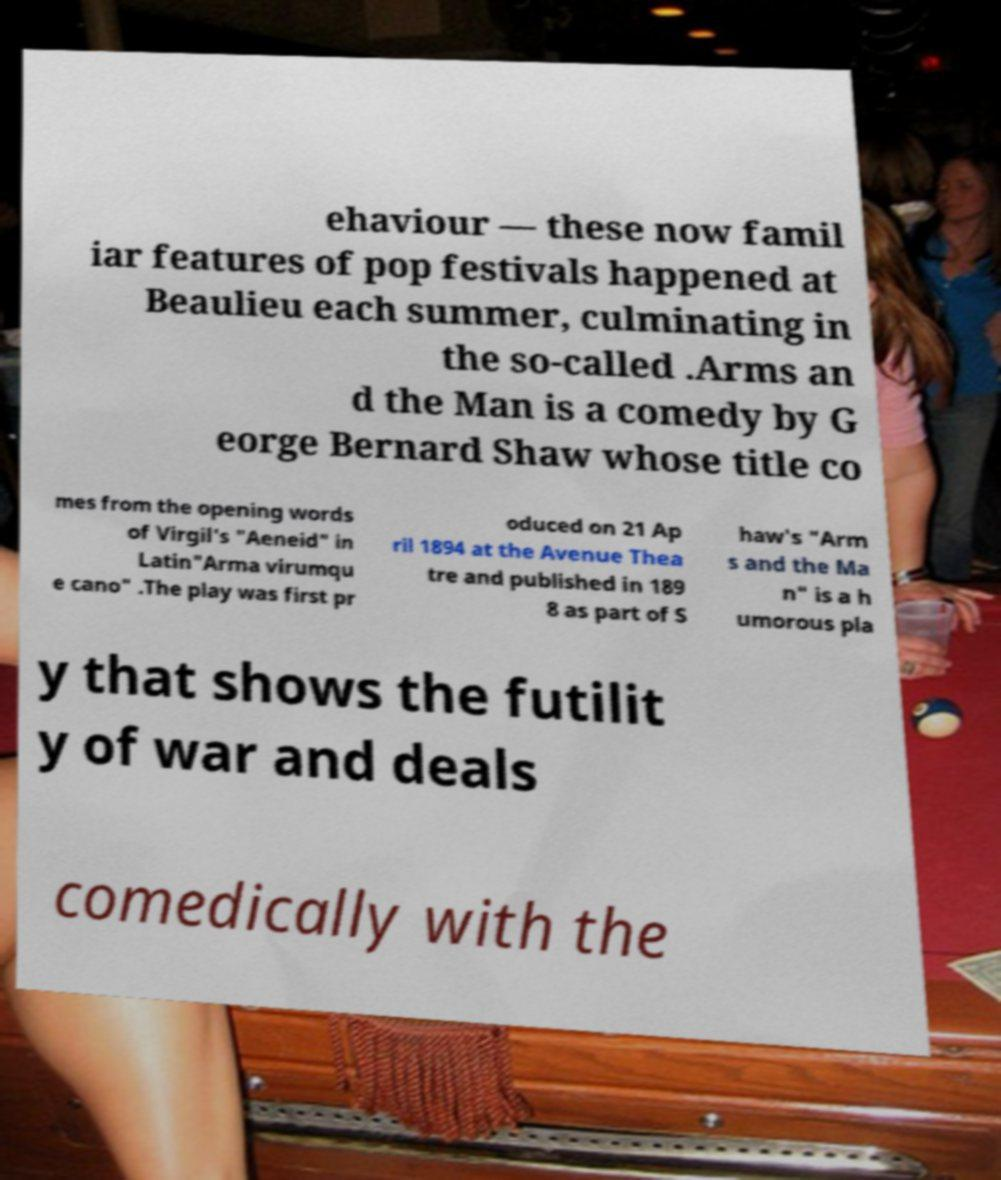What messages or text are displayed in this image? I need them in a readable, typed format. ehaviour — these now famil iar features of pop festivals happened at Beaulieu each summer, culminating in the so-called .Arms an d the Man is a comedy by G eorge Bernard Shaw whose title co mes from the opening words of Virgil's "Aeneid" in Latin"Arma virumqu e cano" .The play was first pr oduced on 21 Ap ril 1894 at the Avenue Thea tre and published in 189 8 as part of S haw's "Arm s and the Ma n" is a h umorous pla y that shows the futilit y of war and deals comedically with the 